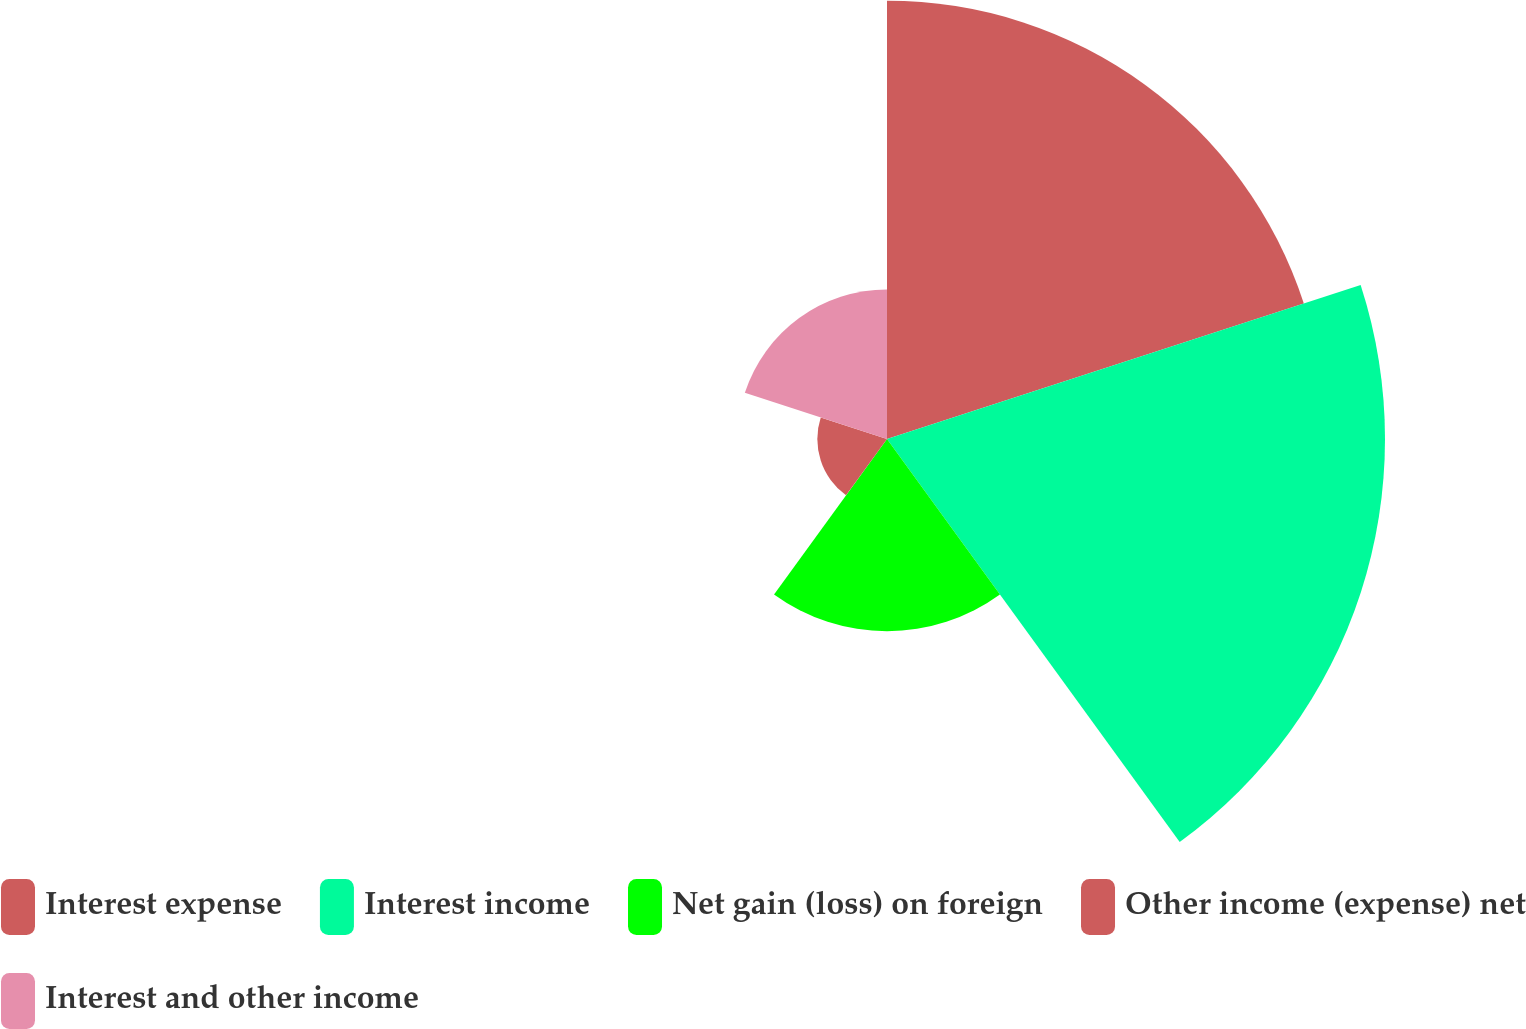Convert chart. <chart><loc_0><loc_0><loc_500><loc_500><pie_chart><fcel>Interest expense<fcel>Interest income<fcel>Net gain (loss) on foreign<fcel>Other income (expense) net<fcel>Interest and other income<nl><fcel>32.52%<fcel>36.95%<fcel>14.26%<fcel>5.17%<fcel>11.09%<nl></chart> 